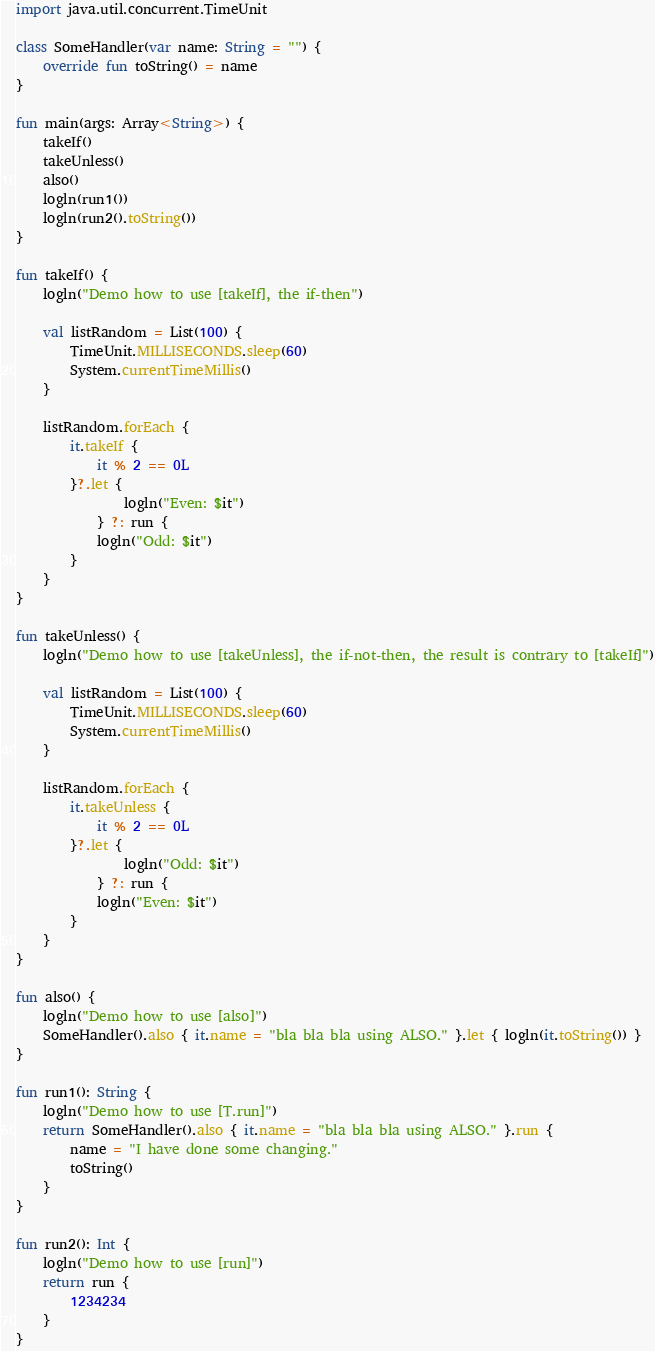Convert code to text. <code><loc_0><loc_0><loc_500><loc_500><_Kotlin_>import java.util.concurrent.TimeUnit

class SomeHandler(var name: String = "") {
    override fun toString() = name
}

fun main(args: Array<String>) {
    takeIf()
    takeUnless()
    also()
    logln(run1())
    logln(run2().toString())
}

fun takeIf() {
    logln("Demo how to use [takeIf], the if-then")

    val listRandom = List(100) {
        TimeUnit.MILLISECONDS.sleep(60)
        System.currentTimeMillis()
    }

    listRandom.forEach {
        it.takeIf {
            it % 2 == 0L
        }?.let {
                logln("Even: $it")
            } ?: run {
            logln("Odd: $it")
        }
    }
}

fun takeUnless() {
    logln("Demo how to use [takeUnless], the if-not-then, the result is contrary to [takeIf]")

    val listRandom = List(100) {
        TimeUnit.MILLISECONDS.sleep(60)
        System.currentTimeMillis()
    }

    listRandom.forEach {
        it.takeUnless {
            it % 2 == 0L
        }?.let {
                logln("Odd: $it")
            } ?: run {
            logln("Even: $it")
        }
    }
}

fun also() {
    logln("Demo how to use [also]")
    SomeHandler().also { it.name = "bla bla bla using ALSO." }.let { logln(it.toString()) }
}

fun run1(): String {
    logln("Demo how to use [T.run]")
    return SomeHandler().also { it.name = "bla bla bla using ALSO." }.run {
        name = "I have done some changing."
        toString()
    }
}

fun run2(): Int {
    logln("Demo how to use [run]")
    return run {
        1234234
    }
}</code> 